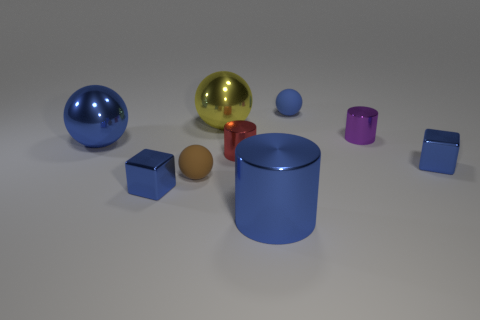Subtract all red cylinders. How many cylinders are left? 2 Add 1 blue metallic objects. How many objects exist? 10 Subtract all brown balls. How many balls are left? 3 Subtract 1 red cylinders. How many objects are left? 8 Subtract all balls. How many objects are left? 5 Subtract 2 balls. How many balls are left? 2 Subtract all gray cylinders. Subtract all red spheres. How many cylinders are left? 3 Subtract all gray cylinders. How many red balls are left? 0 Subtract all small blue rubber balls. Subtract all small spheres. How many objects are left? 6 Add 5 small brown balls. How many small brown balls are left? 6 